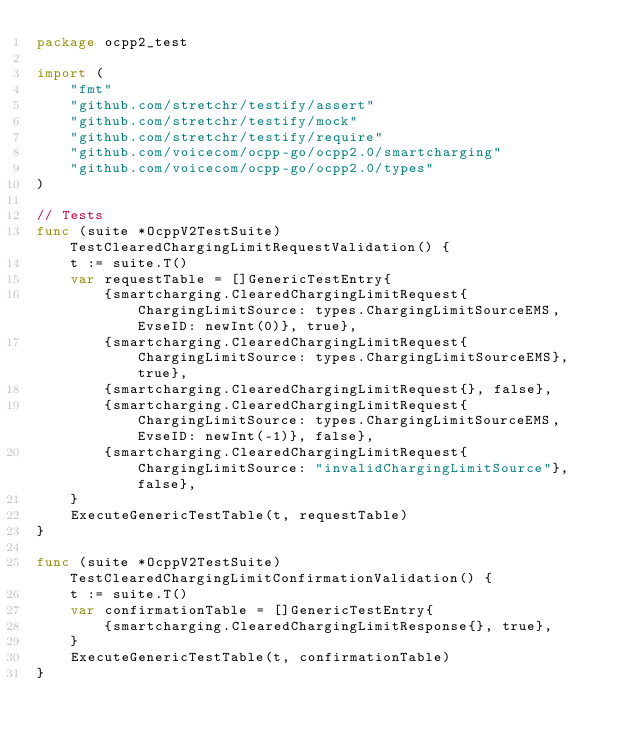<code> <loc_0><loc_0><loc_500><loc_500><_Go_>package ocpp2_test

import (
	"fmt"
	"github.com/stretchr/testify/assert"
	"github.com/stretchr/testify/mock"
	"github.com/stretchr/testify/require"
	"github.com/voicecom/ocpp-go/ocpp2.0/smartcharging"
	"github.com/voicecom/ocpp-go/ocpp2.0/types"
)

// Tests
func (suite *OcppV2TestSuite) TestClearedChargingLimitRequestValidation() {
	t := suite.T()
	var requestTable = []GenericTestEntry{
		{smartcharging.ClearedChargingLimitRequest{ChargingLimitSource: types.ChargingLimitSourceEMS, EvseID: newInt(0)}, true},
		{smartcharging.ClearedChargingLimitRequest{ChargingLimitSource: types.ChargingLimitSourceEMS}, true},
		{smartcharging.ClearedChargingLimitRequest{}, false},
		{smartcharging.ClearedChargingLimitRequest{ChargingLimitSource: types.ChargingLimitSourceEMS, EvseID: newInt(-1)}, false},
		{smartcharging.ClearedChargingLimitRequest{ChargingLimitSource: "invalidChargingLimitSource"}, false},
	}
	ExecuteGenericTestTable(t, requestTable)
}

func (suite *OcppV2TestSuite) TestClearedChargingLimitConfirmationValidation() {
	t := suite.T()
	var confirmationTable = []GenericTestEntry{
		{smartcharging.ClearedChargingLimitResponse{}, true},
	}
	ExecuteGenericTestTable(t, confirmationTable)
}
</code> 